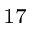Convert formula to latex. <formula><loc_0><loc_0><loc_500><loc_500>^ { 1 7 }</formula> 